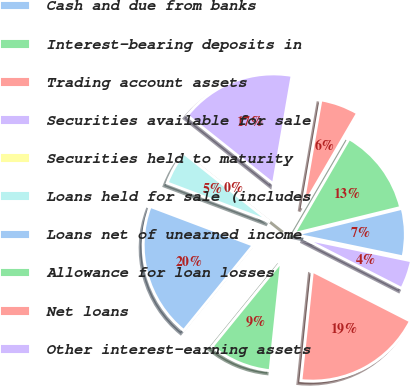Convert chart to OTSL. <chart><loc_0><loc_0><loc_500><loc_500><pie_chart><fcel>Cash and due from banks<fcel>Interest-bearing deposits in<fcel>Trading account assets<fcel>Securities available for sale<fcel>Securities held to maturity<fcel>Loans held for sale (includes<fcel>Loans net of unearned income<fcel>Allowance for loan losses<fcel>Net loans<fcel>Other interest-earning assets<nl><fcel>7.09%<fcel>12.77%<fcel>5.67%<fcel>17.02%<fcel>0.0%<fcel>4.96%<fcel>19.86%<fcel>9.22%<fcel>19.15%<fcel>4.26%<nl></chart> 